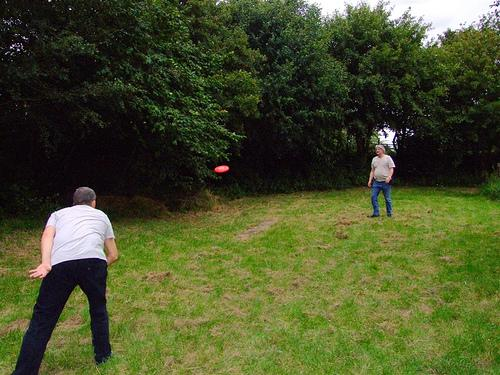Question: what are the men doing?
Choices:
A. Running.
B. Playing frisbee.
C. Riding bikes.
D. Flying kites.
Answer with the letter. Answer: B Question: why is the man in the foreground leaning forward?
Choices:
A. He just threw the frisbee.
B. To retrieve something.
C. Trying to listen in.
D. Posing for a picture.
Answer with the letter. Answer: A Question: what surrounds the area where the men are playing?
Choices:
A. Buildings.
B. Houses.
C. Trees.
D. Cars.
Answer with the letter. Answer: C 